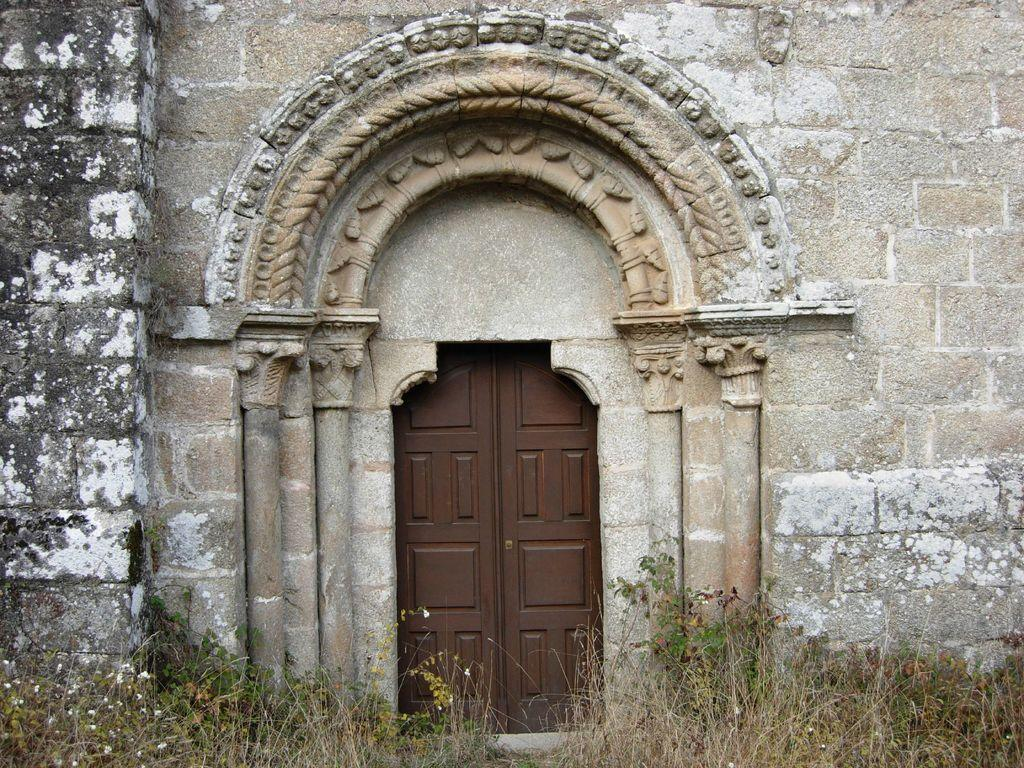What types of vegetation can be seen in the front of the image? There are flowers and plants in the front of the image. What type of structure is visible in the background of the image? There is a building in the background of the image. Can you describe a specific feature of the image? There is a door visible in the image. What part of the digestive system can be seen in the image? There is no part of the digestive system present in the image. Can you describe the branch of the tree in the image? There is no tree or branch present in the image. 